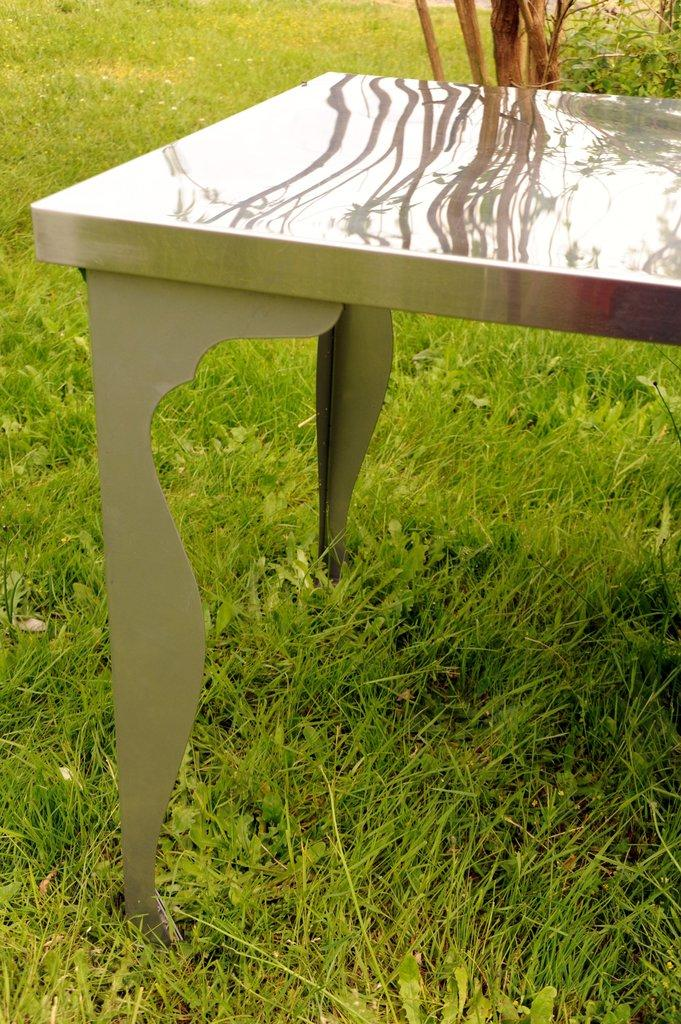What type of surface is visible in the image? There is a grass surface in the image. What is placed on the grass surface? There is a table on the grass surface. What can be seen behind the table? There are plants visible behind the table. What type of wine is being served on the grass surface in the image? There is no wine present in the image; it only features a grass surface, a table, and plants. 